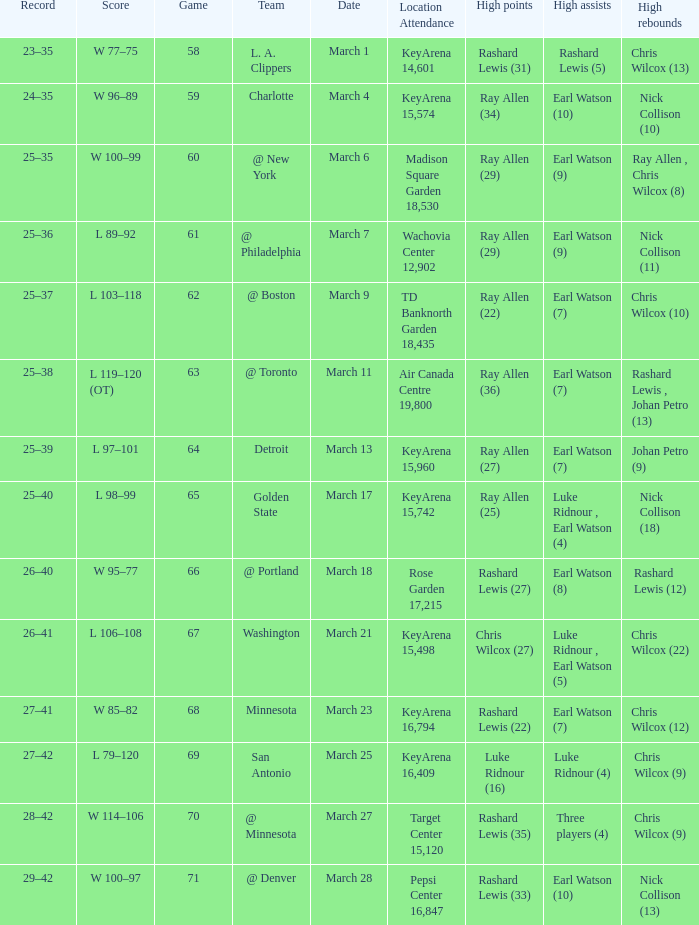What was the record after the game against Washington? 26–41. 